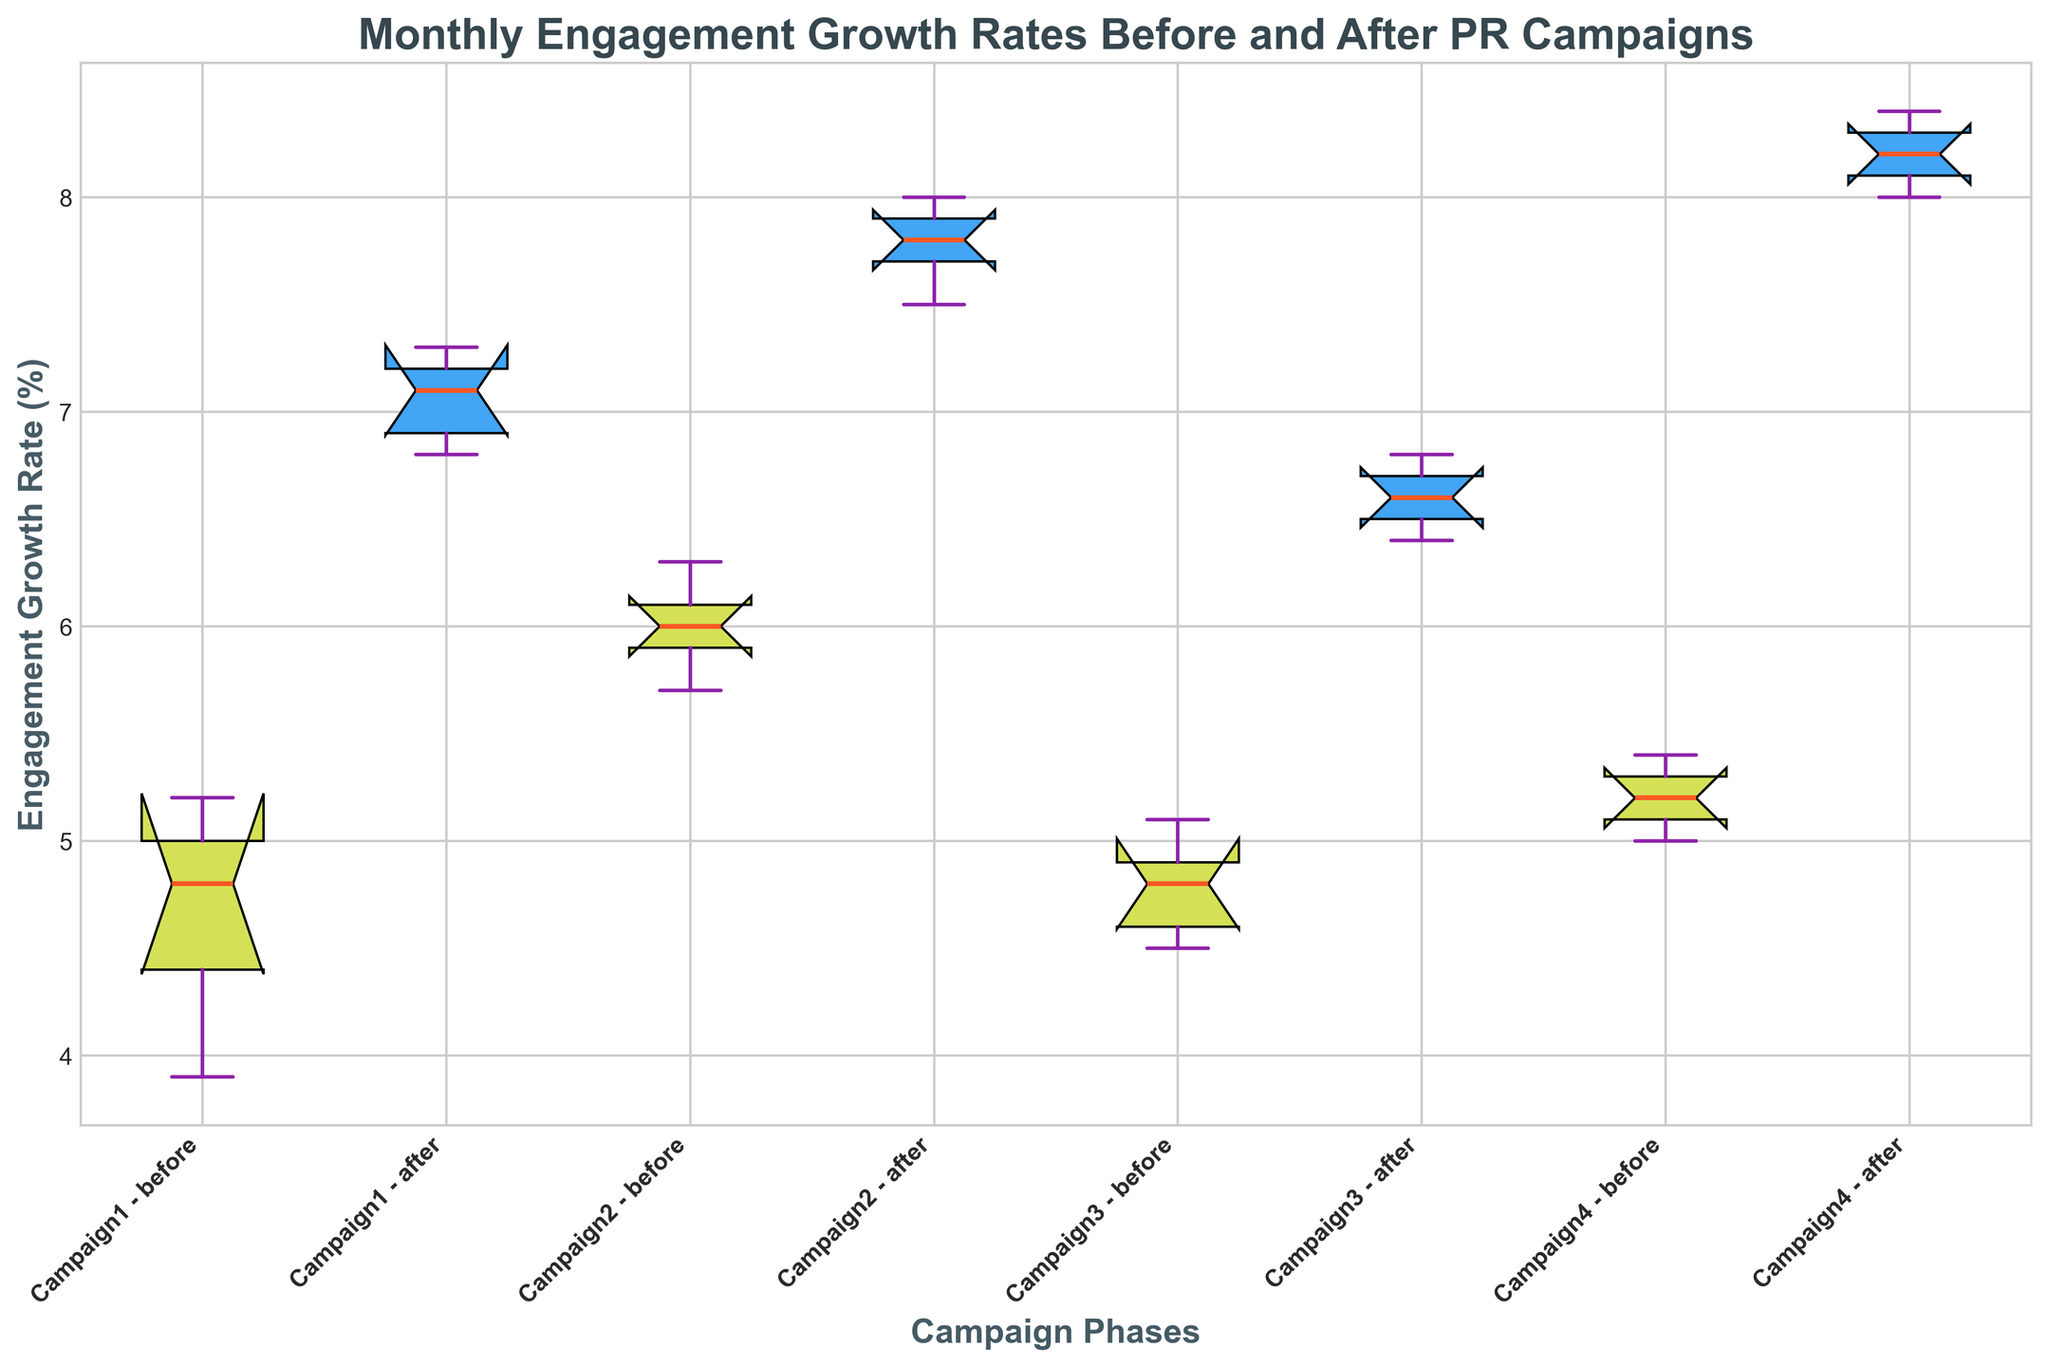Which campaign shows the highest median engagement growth rate after the PR campaign? The box plot shows the median values as orange lines within each box. By comparing the median lines for the 'after' phase of each campaign, Campaign 4 has the highest median value.
Answer: Campaign 4 What is the interquartile range (IQR) for Campaign 2 before the PR campaign? The IQR is the difference between the third quartile (Q3) and the first quartile (Q1). For Campaign 2 before the PR campaign, Q3 is around 6.1, and Q1 is around 5.7. Therefore, IQR = 6.1 - 5.7.
Answer: 0.4 Which campaign experienced the smallest change in median engagement growth rates from before to after the PR campaign? Compare the change in median values before and after the PR campaigns for each campaign. Campaign 3 shows the smallest change in the orange lines representing the medians.
Answer: Campaign 3 Which campaign has the widest spread in engagement growth rates for the 'after' phase? The spread can be evaluated by looking at the length of the box and whiskers for the 'after' phase. Campaign 4 shows the widest spread in engagement growth rates after the PR campaign.
Answer: Campaign 4 Is there any campaign where the median engagement growth rate decreased after the PR campaign? Look for any campaign where the orange median line in the 'after' phase is lower than in the 'before' phase. In the plot, all campaigns show an increase in the median engagement growth rate after the PR campaign.
Answer: No What is the difference in the median engagement growth rate before and after the PR campaign for Campaign 1? Find the orange median lines for Campaign 1 before and after the PR campaign. The median before is around 4.8, and after is around 7.1. The difference is 7.1 - 4.8.
Answer: 2.3 Which campaign has the tightest clustering of engagement growth rates in the 'before' phase? Tight clustering can be identified by the smallest box size in the 'before' phase. Campaign 4 has the tightest clustering as indicated by the smallest box.
Answer: Campaign 4 